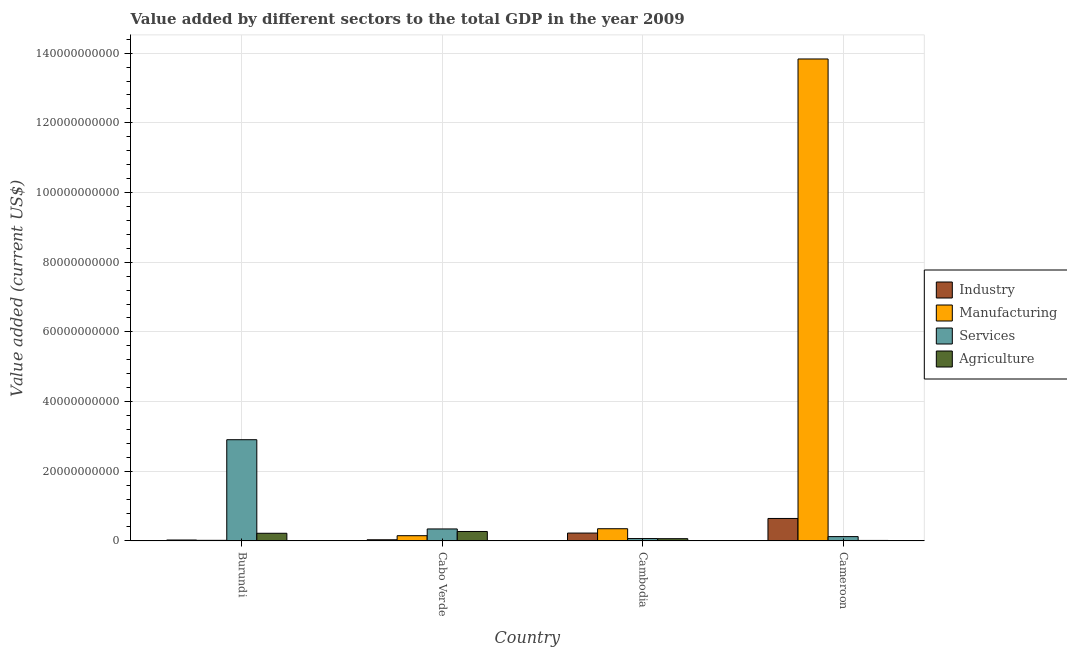How many groups of bars are there?
Make the answer very short. 4. Are the number of bars per tick equal to the number of legend labels?
Make the answer very short. Yes. How many bars are there on the 1st tick from the right?
Your answer should be compact. 4. What is the label of the 4th group of bars from the left?
Offer a terse response. Cameroon. What is the value added by manufacturing sector in Cambodia?
Give a very brief answer. 3.50e+09. Across all countries, what is the maximum value added by agricultural sector?
Keep it short and to the point. 2.71e+09. Across all countries, what is the minimum value added by agricultural sector?
Offer a very short reply. 1.42e+08. In which country was the value added by agricultural sector maximum?
Ensure brevity in your answer.  Cabo Verde. In which country was the value added by services sector minimum?
Keep it short and to the point. Cambodia. What is the total value added by services sector in the graph?
Your response must be concise. 3.44e+1. What is the difference between the value added by services sector in Cabo Verde and that in Cambodia?
Offer a very short reply. 2.76e+09. What is the difference between the value added by agricultural sector in Cambodia and the value added by manufacturing sector in Cabo Verde?
Provide a succinct answer. -8.56e+08. What is the average value added by agricultural sector per country?
Your answer should be compact. 1.42e+09. What is the difference between the value added by agricultural sector and value added by services sector in Cambodia?
Make the answer very short. -3.66e+07. In how many countries, is the value added by agricultural sector greater than 128000000000 US$?
Your answer should be very brief. 0. What is the ratio of the value added by industrial sector in Cambodia to that in Cameroon?
Make the answer very short. 0.35. What is the difference between the highest and the second highest value added by manufacturing sector?
Your answer should be compact. 1.35e+11. What is the difference between the highest and the lowest value added by manufacturing sector?
Your response must be concise. 1.38e+11. In how many countries, is the value added by industrial sector greater than the average value added by industrial sector taken over all countries?
Provide a succinct answer. 1. What does the 3rd bar from the left in Burundi represents?
Ensure brevity in your answer.  Services. What does the 2nd bar from the right in Burundi represents?
Ensure brevity in your answer.  Services. Is it the case that in every country, the sum of the value added by industrial sector and value added by manufacturing sector is greater than the value added by services sector?
Provide a succinct answer. No. How many bars are there?
Ensure brevity in your answer.  16. What is the difference between two consecutive major ticks on the Y-axis?
Ensure brevity in your answer.  2.00e+1. Does the graph contain any zero values?
Offer a terse response. No. Does the graph contain grids?
Offer a very short reply. Yes. Where does the legend appear in the graph?
Offer a very short reply. Center right. How many legend labels are there?
Ensure brevity in your answer.  4. What is the title of the graph?
Provide a succinct answer. Value added by different sectors to the total GDP in the year 2009. Does "Third 20% of population" appear as one of the legend labels in the graph?
Provide a succinct answer. No. What is the label or title of the X-axis?
Offer a terse response. Country. What is the label or title of the Y-axis?
Ensure brevity in your answer.  Value added (current US$). What is the Value added (current US$) of Industry in Burundi?
Keep it short and to the point. 2.64e+08. What is the Value added (current US$) in Manufacturing in Burundi?
Ensure brevity in your answer.  1.69e+08. What is the Value added (current US$) in Services in Burundi?
Provide a succinct answer. 2.91e+1. What is the Value added (current US$) in Agriculture in Burundi?
Your answer should be compact. 2.20e+09. What is the Value added (current US$) of Industry in Cabo Verde?
Give a very brief answer. 3.30e+08. What is the Value added (current US$) of Manufacturing in Cabo Verde?
Keep it short and to the point. 1.50e+09. What is the Value added (current US$) in Services in Cabo Verde?
Ensure brevity in your answer.  3.44e+09. What is the Value added (current US$) in Agriculture in Cabo Verde?
Offer a terse response. 2.71e+09. What is the Value added (current US$) in Industry in Cambodia?
Offer a terse response. 2.25e+09. What is the Value added (current US$) of Manufacturing in Cambodia?
Provide a succinct answer. 3.50e+09. What is the Value added (current US$) in Services in Cambodia?
Give a very brief answer. 6.80e+08. What is the Value added (current US$) of Agriculture in Cambodia?
Give a very brief answer. 6.44e+08. What is the Value added (current US$) in Industry in Cameroon?
Make the answer very short. 6.45e+09. What is the Value added (current US$) in Manufacturing in Cameroon?
Make the answer very short. 1.38e+11. What is the Value added (current US$) in Services in Cameroon?
Your answer should be very brief. 1.24e+09. What is the Value added (current US$) of Agriculture in Cameroon?
Your answer should be very brief. 1.42e+08. Across all countries, what is the maximum Value added (current US$) in Industry?
Your response must be concise. 6.45e+09. Across all countries, what is the maximum Value added (current US$) in Manufacturing?
Offer a terse response. 1.38e+11. Across all countries, what is the maximum Value added (current US$) of Services?
Provide a short and direct response. 2.91e+1. Across all countries, what is the maximum Value added (current US$) of Agriculture?
Your answer should be compact. 2.71e+09. Across all countries, what is the minimum Value added (current US$) of Industry?
Your answer should be very brief. 2.64e+08. Across all countries, what is the minimum Value added (current US$) in Manufacturing?
Provide a succinct answer. 1.69e+08. Across all countries, what is the minimum Value added (current US$) in Services?
Your answer should be compact. 6.80e+08. Across all countries, what is the minimum Value added (current US$) of Agriculture?
Your answer should be very brief. 1.42e+08. What is the total Value added (current US$) in Industry in the graph?
Offer a terse response. 9.30e+09. What is the total Value added (current US$) in Manufacturing in the graph?
Give a very brief answer. 1.44e+11. What is the total Value added (current US$) of Services in the graph?
Provide a short and direct response. 3.44e+1. What is the total Value added (current US$) in Agriculture in the graph?
Keep it short and to the point. 5.70e+09. What is the difference between the Value added (current US$) in Industry in Burundi and that in Cabo Verde?
Offer a terse response. -6.56e+07. What is the difference between the Value added (current US$) in Manufacturing in Burundi and that in Cabo Verde?
Your response must be concise. -1.33e+09. What is the difference between the Value added (current US$) in Services in Burundi and that in Cabo Verde?
Provide a short and direct response. 2.56e+1. What is the difference between the Value added (current US$) in Agriculture in Burundi and that in Cabo Verde?
Make the answer very short. -5.12e+08. What is the difference between the Value added (current US$) of Industry in Burundi and that in Cambodia?
Your answer should be compact. -1.99e+09. What is the difference between the Value added (current US$) of Manufacturing in Burundi and that in Cambodia?
Make the answer very short. -3.33e+09. What is the difference between the Value added (current US$) of Services in Burundi and that in Cambodia?
Your answer should be very brief. 2.84e+1. What is the difference between the Value added (current US$) in Agriculture in Burundi and that in Cambodia?
Your answer should be compact. 1.55e+09. What is the difference between the Value added (current US$) of Industry in Burundi and that in Cameroon?
Your answer should be compact. -6.18e+09. What is the difference between the Value added (current US$) of Manufacturing in Burundi and that in Cameroon?
Your answer should be compact. -1.38e+11. What is the difference between the Value added (current US$) of Services in Burundi and that in Cameroon?
Ensure brevity in your answer.  2.78e+1. What is the difference between the Value added (current US$) of Agriculture in Burundi and that in Cameroon?
Offer a terse response. 2.06e+09. What is the difference between the Value added (current US$) in Industry in Cabo Verde and that in Cambodia?
Your answer should be compact. -1.92e+09. What is the difference between the Value added (current US$) of Manufacturing in Cabo Verde and that in Cambodia?
Your answer should be compact. -2.00e+09. What is the difference between the Value added (current US$) of Services in Cabo Verde and that in Cambodia?
Your response must be concise. 2.76e+09. What is the difference between the Value added (current US$) in Agriculture in Cabo Verde and that in Cambodia?
Your answer should be compact. 2.07e+09. What is the difference between the Value added (current US$) of Industry in Cabo Verde and that in Cameroon?
Your answer should be very brief. -6.12e+09. What is the difference between the Value added (current US$) in Manufacturing in Cabo Verde and that in Cameroon?
Keep it short and to the point. -1.37e+11. What is the difference between the Value added (current US$) in Services in Cabo Verde and that in Cameroon?
Provide a short and direct response. 2.20e+09. What is the difference between the Value added (current US$) in Agriculture in Cabo Verde and that in Cameroon?
Make the answer very short. 2.57e+09. What is the difference between the Value added (current US$) of Industry in Cambodia and that in Cameroon?
Make the answer very short. -4.20e+09. What is the difference between the Value added (current US$) of Manufacturing in Cambodia and that in Cameroon?
Provide a succinct answer. -1.35e+11. What is the difference between the Value added (current US$) in Services in Cambodia and that in Cameroon?
Give a very brief answer. -5.59e+08. What is the difference between the Value added (current US$) of Agriculture in Cambodia and that in Cameroon?
Your answer should be very brief. 5.01e+08. What is the difference between the Value added (current US$) of Industry in Burundi and the Value added (current US$) of Manufacturing in Cabo Verde?
Keep it short and to the point. -1.24e+09. What is the difference between the Value added (current US$) of Industry in Burundi and the Value added (current US$) of Services in Cabo Verde?
Offer a terse response. -3.17e+09. What is the difference between the Value added (current US$) of Industry in Burundi and the Value added (current US$) of Agriculture in Cabo Verde?
Your answer should be very brief. -2.45e+09. What is the difference between the Value added (current US$) in Manufacturing in Burundi and the Value added (current US$) in Services in Cabo Verde?
Offer a terse response. -3.27e+09. What is the difference between the Value added (current US$) in Manufacturing in Burundi and the Value added (current US$) in Agriculture in Cabo Verde?
Ensure brevity in your answer.  -2.54e+09. What is the difference between the Value added (current US$) of Services in Burundi and the Value added (current US$) of Agriculture in Cabo Verde?
Offer a very short reply. 2.63e+1. What is the difference between the Value added (current US$) in Industry in Burundi and the Value added (current US$) in Manufacturing in Cambodia?
Your answer should be very brief. -3.24e+09. What is the difference between the Value added (current US$) in Industry in Burundi and the Value added (current US$) in Services in Cambodia?
Provide a succinct answer. -4.16e+08. What is the difference between the Value added (current US$) of Industry in Burundi and the Value added (current US$) of Agriculture in Cambodia?
Offer a terse response. -3.80e+08. What is the difference between the Value added (current US$) of Manufacturing in Burundi and the Value added (current US$) of Services in Cambodia?
Make the answer very short. -5.11e+08. What is the difference between the Value added (current US$) of Manufacturing in Burundi and the Value added (current US$) of Agriculture in Cambodia?
Your answer should be very brief. -4.75e+08. What is the difference between the Value added (current US$) in Services in Burundi and the Value added (current US$) in Agriculture in Cambodia?
Ensure brevity in your answer.  2.84e+1. What is the difference between the Value added (current US$) in Industry in Burundi and the Value added (current US$) in Manufacturing in Cameroon?
Provide a succinct answer. -1.38e+11. What is the difference between the Value added (current US$) of Industry in Burundi and the Value added (current US$) of Services in Cameroon?
Offer a very short reply. -9.76e+08. What is the difference between the Value added (current US$) of Industry in Burundi and the Value added (current US$) of Agriculture in Cameroon?
Make the answer very short. 1.22e+08. What is the difference between the Value added (current US$) in Manufacturing in Burundi and the Value added (current US$) in Services in Cameroon?
Provide a short and direct response. -1.07e+09. What is the difference between the Value added (current US$) of Manufacturing in Burundi and the Value added (current US$) of Agriculture in Cameroon?
Offer a very short reply. 2.67e+07. What is the difference between the Value added (current US$) in Services in Burundi and the Value added (current US$) in Agriculture in Cameroon?
Offer a terse response. 2.89e+1. What is the difference between the Value added (current US$) in Industry in Cabo Verde and the Value added (current US$) in Manufacturing in Cambodia?
Your answer should be compact. -3.17e+09. What is the difference between the Value added (current US$) of Industry in Cabo Verde and the Value added (current US$) of Services in Cambodia?
Ensure brevity in your answer.  -3.51e+08. What is the difference between the Value added (current US$) of Industry in Cabo Verde and the Value added (current US$) of Agriculture in Cambodia?
Provide a succinct answer. -3.14e+08. What is the difference between the Value added (current US$) of Manufacturing in Cabo Verde and the Value added (current US$) of Services in Cambodia?
Offer a very short reply. 8.19e+08. What is the difference between the Value added (current US$) of Manufacturing in Cabo Verde and the Value added (current US$) of Agriculture in Cambodia?
Offer a very short reply. 8.56e+08. What is the difference between the Value added (current US$) of Services in Cabo Verde and the Value added (current US$) of Agriculture in Cambodia?
Offer a very short reply. 2.79e+09. What is the difference between the Value added (current US$) of Industry in Cabo Verde and the Value added (current US$) of Manufacturing in Cameroon?
Keep it short and to the point. -1.38e+11. What is the difference between the Value added (current US$) in Industry in Cabo Verde and the Value added (current US$) in Services in Cameroon?
Your answer should be compact. -9.10e+08. What is the difference between the Value added (current US$) in Industry in Cabo Verde and the Value added (current US$) in Agriculture in Cameroon?
Provide a succinct answer. 1.87e+08. What is the difference between the Value added (current US$) in Manufacturing in Cabo Verde and the Value added (current US$) in Services in Cameroon?
Provide a succinct answer. 2.60e+08. What is the difference between the Value added (current US$) in Manufacturing in Cabo Verde and the Value added (current US$) in Agriculture in Cameroon?
Your response must be concise. 1.36e+09. What is the difference between the Value added (current US$) of Services in Cabo Verde and the Value added (current US$) of Agriculture in Cameroon?
Your answer should be very brief. 3.29e+09. What is the difference between the Value added (current US$) of Industry in Cambodia and the Value added (current US$) of Manufacturing in Cameroon?
Your answer should be compact. -1.36e+11. What is the difference between the Value added (current US$) in Industry in Cambodia and the Value added (current US$) in Services in Cameroon?
Provide a short and direct response. 1.01e+09. What is the difference between the Value added (current US$) of Industry in Cambodia and the Value added (current US$) of Agriculture in Cameroon?
Offer a terse response. 2.11e+09. What is the difference between the Value added (current US$) of Manufacturing in Cambodia and the Value added (current US$) of Services in Cameroon?
Offer a terse response. 2.26e+09. What is the difference between the Value added (current US$) of Manufacturing in Cambodia and the Value added (current US$) of Agriculture in Cameroon?
Your response must be concise. 3.36e+09. What is the difference between the Value added (current US$) in Services in Cambodia and the Value added (current US$) in Agriculture in Cameroon?
Your answer should be very brief. 5.38e+08. What is the average Value added (current US$) in Industry per country?
Give a very brief answer. 2.32e+09. What is the average Value added (current US$) in Manufacturing per country?
Provide a succinct answer. 3.59e+1. What is the average Value added (current US$) of Services per country?
Ensure brevity in your answer.  8.60e+09. What is the average Value added (current US$) of Agriculture per country?
Give a very brief answer. 1.42e+09. What is the difference between the Value added (current US$) of Industry and Value added (current US$) of Manufacturing in Burundi?
Your answer should be compact. 9.50e+07. What is the difference between the Value added (current US$) in Industry and Value added (current US$) in Services in Burundi?
Your answer should be very brief. -2.88e+1. What is the difference between the Value added (current US$) of Industry and Value added (current US$) of Agriculture in Burundi?
Your answer should be very brief. -1.93e+09. What is the difference between the Value added (current US$) in Manufacturing and Value added (current US$) in Services in Burundi?
Give a very brief answer. -2.89e+1. What is the difference between the Value added (current US$) in Manufacturing and Value added (current US$) in Agriculture in Burundi?
Your answer should be compact. -2.03e+09. What is the difference between the Value added (current US$) of Services and Value added (current US$) of Agriculture in Burundi?
Your answer should be compact. 2.69e+1. What is the difference between the Value added (current US$) of Industry and Value added (current US$) of Manufacturing in Cabo Verde?
Ensure brevity in your answer.  -1.17e+09. What is the difference between the Value added (current US$) of Industry and Value added (current US$) of Services in Cabo Verde?
Your answer should be compact. -3.11e+09. What is the difference between the Value added (current US$) of Industry and Value added (current US$) of Agriculture in Cabo Verde?
Your answer should be very brief. -2.38e+09. What is the difference between the Value added (current US$) in Manufacturing and Value added (current US$) in Services in Cabo Verde?
Ensure brevity in your answer.  -1.94e+09. What is the difference between the Value added (current US$) in Manufacturing and Value added (current US$) in Agriculture in Cabo Verde?
Ensure brevity in your answer.  -1.21e+09. What is the difference between the Value added (current US$) of Services and Value added (current US$) of Agriculture in Cabo Verde?
Keep it short and to the point. 7.26e+08. What is the difference between the Value added (current US$) of Industry and Value added (current US$) of Manufacturing in Cambodia?
Your answer should be very brief. -1.25e+09. What is the difference between the Value added (current US$) in Industry and Value added (current US$) in Services in Cambodia?
Your answer should be very brief. 1.57e+09. What is the difference between the Value added (current US$) in Industry and Value added (current US$) in Agriculture in Cambodia?
Offer a very short reply. 1.61e+09. What is the difference between the Value added (current US$) in Manufacturing and Value added (current US$) in Services in Cambodia?
Give a very brief answer. 2.82e+09. What is the difference between the Value added (current US$) in Manufacturing and Value added (current US$) in Agriculture in Cambodia?
Your answer should be compact. 2.86e+09. What is the difference between the Value added (current US$) in Services and Value added (current US$) in Agriculture in Cambodia?
Your answer should be very brief. 3.66e+07. What is the difference between the Value added (current US$) of Industry and Value added (current US$) of Manufacturing in Cameroon?
Offer a very short reply. -1.32e+11. What is the difference between the Value added (current US$) in Industry and Value added (current US$) in Services in Cameroon?
Offer a terse response. 5.21e+09. What is the difference between the Value added (current US$) in Industry and Value added (current US$) in Agriculture in Cameroon?
Ensure brevity in your answer.  6.31e+09. What is the difference between the Value added (current US$) in Manufacturing and Value added (current US$) in Services in Cameroon?
Offer a terse response. 1.37e+11. What is the difference between the Value added (current US$) in Manufacturing and Value added (current US$) in Agriculture in Cameroon?
Provide a succinct answer. 1.38e+11. What is the difference between the Value added (current US$) of Services and Value added (current US$) of Agriculture in Cameroon?
Keep it short and to the point. 1.10e+09. What is the ratio of the Value added (current US$) of Industry in Burundi to that in Cabo Verde?
Your answer should be very brief. 0.8. What is the ratio of the Value added (current US$) of Manufacturing in Burundi to that in Cabo Verde?
Provide a succinct answer. 0.11. What is the ratio of the Value added (current US$) in Services in Burundi to that in Cabo Verde?
Offer a terse response. 8.45. What is the ratio of the Value added (current US$) in Agriculture in Burundi to that in Cabo Verde?
Provide a succinct answer. 0.81. What is the ratio of the Value added (current US$) in Industry in Burundi to that in Cambodia?
Your answer should be very brief. 0.12. What is the ratio of the Value added (current US$) in Manufacturing in Burundi to that in Cambodia?
Give a very brief answer. 0.05. What is the ratio of the Value added (current US$) in Services in Burundi to that in Cambodia?
Ensure brevity in your answer.  42.71. What is the ratio of the Value added (current US$) of Agriculture in Burundi to that in Cambodia?
Make the answer very short. 3.42. What is the ratio of the Value added (current US$) in Industry in Burundi to that in Cameroon?
Make the answer very short. 0.04. What is the ratio of the Value added (current US$) of Manufacturing in Burundi to that in Cameroon?
Provide a short and direct response. 0. What is the ratio of the Value added (current US$) in Services in Burundi to that in Cameroon?
Provide a succinct answer. 23.44. What is the ratio of the Value added (current US$) in Agriculture in Burundi to that in Cameroon?
Provide a succinct answer. 15.44. What is the ratio of the Value added (current US$) in Industry in Cabo Verde to that in Cambodia?
Give a very brief answer. 0.15. What is the ratio of the Value added (current US$) of Manufacturing in Cabo Verde to that in Cambodia?
Provide a succinct answer. 0.43. What is the ratio of the Value added (current US$) of Services in Cabo Verde to that in Cambodia?
Your answer should be compact. 5.05. What is the ratio of the Value added (current US$) of Agriculture in Cabo Verde to that in Cambodia?
Your response must be concise. 4.21. What is the ratio of the Value added (current US$) of Industry in Cabo Verde to that in Cameroon?
Give a very brief answer. 0.05. What is the ratio of the Value added (current US$) of Manufacturing in Cabo Verde to that in Cameroon?
Give a very brief answer. 0.01. What is the ratio of the Value added (current US$) of Services in Cabo Verde to that in Cameroon?
Provide a short and direct response. 2.77. What is the ratio of the Value added (current US$) of Agriculture in Cabo Verde to that in Cameroon?
Make the answer very short. 19.04. What is the ratio of the Value added (current US$) in Industry in Cambodia to that in Cameroon?
Your response must be concise. 0.35. What is the ratio of the Value added (current US$) in Manufacturing in Cambodia to that in Cameroon?
Provide a short and direct response. 0.03. What is the ratio of the Value added (current US$) in Services in Cambodia to that in Cameroon?
Your answer should be compact. 0.55. What is the ratio of the Value added (current US$) of Agriculture in Cambodia to that in Cameroon?
Offer a very short reply. 4.52. What is the difference between the highest and the second highest Value added (current US$) of Industry?
Offer a terse response. 4.20e+09. What is the difference between the highest and the second highest Value added (current US$) of Manufacturing?
Your answer should be compact. 1.35e+11. What is the difference between the highest and the second highest Value added (current US$) of Services?
Make the answer very short. 2.56e+1. What is the difference between the highest and the second highest Value added (current US$) of Agriculture?
Provide a short and direct response. 5.12e+08. What is the difference between the highest and the lowest Value added (current US$) of Industry?
Provide a short and direct response. 6.18e+09. What is the difference between the highest and the lowest Value added (current US$) in Manufacturing?
Your response must be concise. 1.38e+11. What is the difference between the highest and the lowest Value added (current US$) in Services?
Keep it short and to the point. 2.84e+1. What is the difference between the highest and the lowest Value added (current US$) in Agriculture?
Give a very brief answer. 2.57e+09. 